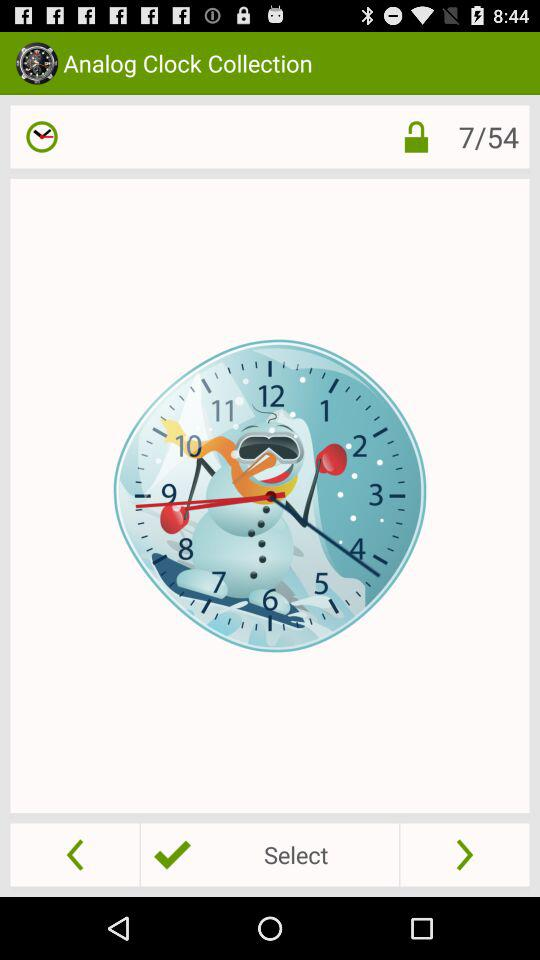Which slide is currently displayed? The currently displayed slide is 7. 